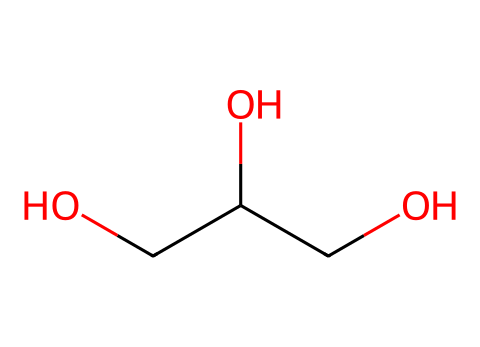What is the molecular formula of the compound represented by the SMILES? In the given SMILES, C(C(CO)O)O, there are three carbon atoms (C), eight hydrogen atoms (H), and four oxygen atoms (O). Therefore, by counting the atoms, we can derive the molecular formula as C3H8O4.
Answer: C3H8O4 How many hydroxyl (–OH) groups are present in the structure? The SMILES notation indicates two separate –OH groups in the molecule (two instances of 'O' followed by hydrogen in the formulas). Thus, this structure contains two hydroxyl groups.
Answer: two Is the compound a carbohydrate, lipid, or protein? This compound, with three carbon atoms and hydroxyl groups, is categorized as a lipid due to the presence of glycerol, which is a backbone for triglycerides, a type of lipid.
Answer: lipid What type of functional group is predominantly present in this compound? The presence of –OH groups identifies alcohols. Given that both functional groups in the molecule are hydroxyl groups, this compound is classified as a triol.
Answer: triol How many carbon chains are present in the structure? In the SMILES representation, the main carbon chain consists of three carbon atoms connected, indicating one chain of three carbons.
Answer: one What role does glycerol play in sports energy gels? Glycerol acts as a humectant in sports energy gels, helping to retain moisture and enhance the energy delivery system for performance.
Answer: humectant 